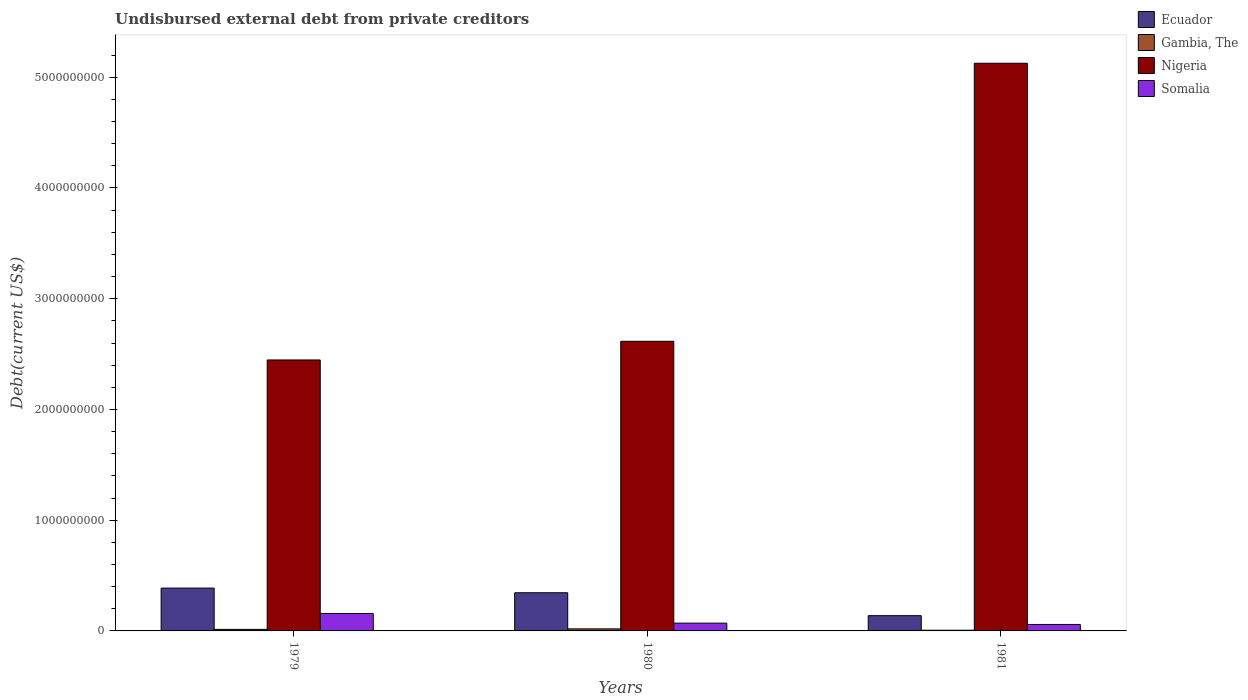How many different coloured bars are there?
Make the answer very short. 4. How many groups of bars are there?
Ensure brevity in your answer.  3. Are the number of bars on each tick of the X-axis equal?
Provide a succinct answer. Yes. How many bars are there on the 1st tick from the left?
Keep it short and to the point. 4. How many bars are there on the 2nd tick from the right?
Make the answer very short. 4. What is the label of the 2nd group of bars from the left?
Provide a succinct answer. 1980. In how many cases, is the number of bars for a given year not equal to the number of legend labels?
Your response must be concise. 0. What is the total debt in Gambia, The in 1980?
Your answer should be very brief. 1.86e+07. Across all years, what is the maximum total debt in Somalia?
Make the answer very short. 1.58e+08. Across all years, what is the minimum total debt in Gambia, The?
Provide a succinct answer. 6.27e+06. What is the total total debt in Ecuador in the graph?
Your answer should be very brief. 8.69e+08. What is the difference between the total debt in Somalia in 1979 and that in 1981?
Your answer should be very brief. 9.94e+07. What is the difference between the total debt in Ecuador in 1981 and the total debt in Somalia in 1979?
Make the answer very short. -1.98e+07. What is the average total debt in Gambia, The per year?
Your response must be concise. 1.29e+07. In the year 1981, what is the difference between the total debt in Nigeria and total debt in Ecuador?
Ensure brevity in your answer.  4.99e+09. What is the ratio of the total debt in Somalia in 1979 to that in 1980?
Give a very brief answer. 2.24. Is the total debt in Ecuador in 1980 less than that in 1981?
Your answer should be very brief. No. Is the difference between the total debt in Nigeria in 1979 and 1980 greater than the difference between the total debt in Ecuador in 1979 and 1980?
Your response must be concise. No. What is the difference between the highest and the second highest total debt in Gambia, The?
Your response must be concise. 4.72e+06. What is the difference between the highest and the lowest total debt in Nigeria?
Offer a very short reply. 2.68e+09. In how many years, is the total debt in Somalia greater than the average total debt in Somalia taken over all years?
Give a very brief answer. 1. Is the sum of the total debt in Nigeria in 1980 and 1981 greater than the maximum total debt in Ecuador across all years?
Offer a terse response. Yes. What does the 4th bar from the left in 1979 represents?
Your response must be concise. Somalia. What does the 3rd bar from the right in 1979 represents?
Your response must be concise. Gambia, The. Is it the case that in every year, the sum of the total debt in Nigeria and total debt in Somalia is greater than the total debt in Gambia, The?
Offer a terse response. Yes. How many bars are there?
Provide a succinct answer. 12. Are all the bars in the graph horizontal?
Make the answer very short. No. Are the values on the major ticks of Y-axis written in scientific E-notation?
Your answer should be compact. No. Does the graph contain grids?
Your answer should be compact. No. How are the legend labels stacked?
Your response must be concise. Vertical. What is the title of the graph?
Keep it short and to the point. Undisbursed external debt from private creditors. Does "Monaco" appear as one of the legend labels in the graph?
Provide a succinct answer. No. What is the label or title of the Y-axis?
Your response must be concise. Debt(current US$). What is the Debt(current US$) in Ecuador in 1979?
Your answer should be very brief. 3.87e+08. What is the Debt(current US$) in Gambia, The in 1979?
Ensure brevity in your answer.  1.39e+07. What is the Debt(current US$) of Nigeria in 1979?
Keep it short and to the point. 2.45e+09. What is the Debt(current US$) of Somalia in 1979?
Provide a succinct answer. 1.58e+08. What is the Debt(current US$) of Ecuador in 1980?
Your answer should be compact. 3.45e+08. What is the Debt(current US$) of Gambia, The in 1980?
Your response must be concise. 1.86e+07. What is the Debt(current US$) of Nigeria in 1980?
Your response must be concise. 2.62e+09. What is the Debt(current US$) in Somalia in 1980?
Provide a short and direct response. 7.03e+07. What is the Debt(current US$) in Ecuador in 1981?
Make the answer very short. 1.38e+08. What is the Debt(current US$) in Gambia, The in 1981?
Offer a terse response. 6.27e+06. What is the Debt(current US$) in Nigeria in 1981?
Offer a very short reply. 5.13e+09. What is the Debt(current US$) of Somalia in 1981?
Ensure brevity in your answer.  5.82e+07. Across all years, what is the maximum Debt(current US$) of Ecuador?
Offer a terse response. 3.87e+08. Across all years, what is the maximum Debt(current US$) of Gambia, The?
Give a very brief answer. 1.86e+07. Across all years, what is the maximum Debt(current US$) of Nigeria?
Offer a terse response. 5.13e+09. Across all years, what is the maximum Debt(current US$) of Somalia?
Offer a terse response. 1.58e+08. Across all years, what is the minimum Debt(current US$) in Ecuador?
Your answer should be very brief. 1.38e+08. Across all years, what is the minimum Debt(current US$) of Gambia, The?
Keep it short and to the point. 6.27e+06. Across all years, what is the minimum Debt(current US$) of Nigeria?
Give a very brief answer. 2.45e+09. Across all years, what is the minimum Debt(current US$) in Somalia?
Make the answer very short. 5.82e+07. What is the total Debt(current US$) of Ecuador in the graph?
Provide a succinct answer. 8.69e+08. What is the total Debt(current US$) in Gambia, The in the graph?
Keep it short and to the point. 3.87e+07. What is the total Debt(current US$) in Nigeria in the graph?
Provide a short and direct response. 1.02e+1. What is the total Debt(current US$) of Somalia in the graph?
Your answer should be very brief. 2.86e+08. What is the difference between the Debt(current US$) in Ecuador in 1979 and that in 1980?
Your response must be concise. 4.21e+07. What is the difference between the Debt(current US$) of Gambia, The in 1979 and that in 1980?
Give a very brief answer. -4.72e+06. What is the difference between the Debt(current US$) in Nigeria in 1979 and that in 1980?
Offer a very short reply. -1.69e+08. What is the difference between the Debt(current US$) in Somalia in 1979 and that in 1980?
Ensure brevity in your answer.  8.73e+07. What is the difference between the Debt(current US$) in Ecuador in 1979 and that in 1981?
Ensure brevity in your answer.  2.49e+08. What is the difference between the Debt(current US$) of Gambia, The in 1979 and that in 1981?
Make the answer very short. 7.60e+06. What is the difference between the Debt(current US$) of Nigeria in 1979 and that in 1981?
Your response must be concise. -2.68e+09. What is the difference between the Debt(current US$) in Somalia in 1979 and that in 1981?
Keep it short and to the point. 9.94e+07. What is the difference between the Debt(current US$) in Ecuador in 1980 and that in 1981?
Ensure brevity in your answer.  2.07e+08. What is the difference between the Debt(current US$) of Gambia, The in 1980 and that in 1981?
Offer a terse response. 1.23e+07. What is the difference between the Debt(current US$) of Nigeria in 1980 and that in 1981?
Your answer should be compact. -2.51e+09. What is the difference between the Debt(current US$) in Somalia in 1980 and that in 1981?
Give a very brief answer. 1.21e+07. What is the difference between the Debt(current US$) in Ecuador in 1979 and the Debt(current US$) in Gambia, The in 1980?
Offer a terse response. 3.68e+08. What is the difference between the Debt(current US$) in Ecuador in 1979 and the Debt(current US$) in Nigeria in 1980?
Provide a short and direct response. -2.23e+09. What is the difference between the Debt(current US$) in Ecuador in 1979 and the Debt(current US$) in Somalia in 1980?
Offer a terse response. 3.16e+08. What is the difference between the Debt(current US$) in Gambia, The in 1979 and the Debt(current US$) in Nigeria in 1980?
Your answer should be very brief. -2.60e+09. What is the difference between the Debt(current US$) in Gambia, The in 1979 and the Debt(current US$) in Somalia in 1980?
Provide a succinct answer. -5.65e+07. What is the difference between the Debt(current US$) of Nigeria in 1979 and the Debt(current US$) of Somalia in 1980?
Make the answer very short. 2.38e+09. What is the difference between the Debt(current US$) of Ecuador in 1979 and the Debt(current US$) of Gambia, The in 1981?
Provide a short and direct response. 3.81e+08. What is the difference between the Debt(current US$) in Ecuador in 1979 and the Debt(current US$) in Nigeria in 1981?
Make the answer very short. -4.74e+09. What is the difference between the Debt(current US$) in Ecuador in 1979 and the Debt(current US$) in Somalia in 1981?
Provide a succinct answer. 3.29e+08. What is the difference between the Debt(current US$) in Gambia, The in 1979 and the Debt(current US$) in Nigeria in 1981?
Keep it short and to the point. -5.11e+09. What is the difference between the Debt(current US$) in Gambia, The in 1979 and the Debt(current US$) in Somalia in 1981?
Keep it short and to the point. -4.43e+07. What is the difference between the Debt(current US$) in Nigeria in 1979 and the Debt(current US$) in Somalia in 1981?
Offer a terse response. 2.39e+09. What is the difference between the Debt(current US$) in Ecuador in 1980 and the Debt(current US$) in Gambia, The in 1981?
Offer a terse response. 3.38e+08. What is the difference between the Debt(current US$) of Ecuador in 1980 and the Debt(current US$) of Nigeria in 1981?
Your answer should be very brief. -4.78e+09. What is the difference between the Debt(current US$) in Ecuador in 1980 and the Debt(current US$) in Somalia in 1981?
Your response must be concise. 2.87e+08. What is the difference between the Debt(current US$) in Gambia, The in 1980 and the Debt(current US$) in Nigeria in 1981?
Offer a very short reply. -5.11e+09. What is the difference between the Debt(current US$) in Gambia, The in 1980 and the Debt(current US$) in Somalia in 1981?
Give a very brief answer. -3.96e+07. What is the difference between the Debt(current US$) in Nigeria in 1980 and the Debt(current US$) in Somalia in 1981?
Keep it short and to the point. 2.56e+09. What is the average Debt(current US$) in Ecuador per year?
Keep it short and to the point. 2.90e+08. What is the average Debt(current US$) of Gambia, The per year?
Provide a succinct answer. 1.29e+07. What is the average Debt(current US$) of Nigeria per year?
Keep it short and to the point. 3.40e+09. What is the average Debt(current US$) in Somalia per year?
Provide a succinct answer. 9.54e+07. In the year 1979, what is the difference between the Debt(current US$) in Ecuador and Debt(current US$) in Gambia, The?
Keep it short and to the point. 3.73e+08. In the year 1979, what is the difference between the Debt(current US$) of Ecuador and Debt(current US$) of Nigeria?
Your answer should be very brief. -2.06e+09. In the year 1979, what is the difference between the Debt(current US$) in Ecuador and Debt(current US$) in Somalia?
Give a very brief answer. 2.29e+08. In the year 1979, what is the difference between the Debt(current US$) in Gambia, The and Debt(current US$) in Nigeria?
Give a very brief answer. -2.43e+09. In the year 1979, what is the difference between the Debt(current US$) in Gambia, The and Debt(current US$) in Somalia?
Give a very brief answer. -1.44e+08. In the year 1979, what is the difference between the Debt(current US$) in Nigeria and Debt(current US$) in Somalia?
Offer a terse response. 2.29e+09. In the year 1980, what is the difference between the Debt(current US$) in Ecuador and Debt(current US$) in Gambia, The?
Provide a short and direct response. 3.26e+08. In the year 1980, what is the difference between the Debt(current US$) of Ecuador and Debt(current US$) of Nigeria?
Your answer should be compact. -2.27e+09. In the year 1980, what is the difference between the Debt(current US$) of Ecuador and Debt(current US$) of Somalia?
Make the answer very short. 2.74e+08. In the year 1980, what is the difference between the Debt(current US$) of Gambia, The and Debt(current US$) of Nigeria?
Make the answer very short. -2.60e+09. In the year 1980, what is the difference between the Debt(current US$) of Gambia, The and Debt(current US$) of Somalia?
Provide a succinct answer. -5.17e+07. In the year 1980, what is the difference between the Debt(current US$) of Nigeria and Debt(current US$) of Somalia?
Your answer should be very brief. 2.55e+09. In the year 1981, what is the difference between the Debt(current US$) in Ecuador and Debt(current US$) in Gambia, The?
Your answer should be very brief. 1.32e+08. In the year 1981, what is the difference between the Debt(current US$) of Ecuador and Debt(current US$) of Nigeria?
Offer a terse response. -4.99e+09. In the year 1981, what is the difference between the Debt(current US$) of Ecuador and Debt(current US$) of Somalia?
Offer a very short reply. 7.96e+07. In the year 1981, what is the difference between the Debt(current US$) of Gambia, The and Debt(current US$) of Nigeria?
Give a very brief answer. -5.12e+09. In the year 1981, what is the difference between the Debt(current US$) in Gambia, The and Debt(current US$) in Somalia?
Your answer should be very brief. -5.19e+07. In the year 1981, what is the difference between the Debt(current US$) in Nigeria and Debt(current US$) in Somalia?
Your response must be concise. 5.07e+09. What is the ratio of the Debt(current US$) of Ecuador in 1979 to that in 1980?
Keep it short and to the point. 1.12. What is the ratio of the Debt(current US$) of Gambia, The in 1979 to that in 1980?
Offer a very short reply. 0.75. What is the ratio of the Debt(current US$) in Nigeria in 1979 to that in 1980?
Make the answer very short. 0.94. What is the ratio of the Debt(current US$) of Somalia in 1979 to that in 1980?
Your response must be concise. 2.24. What is the ratio of the Debt(current US$) of Ecuador in 1979 to that in 1981?
Your response must be concise. 2.81. What is the ratio of the Debt(current US$) in Gambia, The in 1979 to that in 1981?
Ensure brevity in your answer.  2.21. What is the ratio of the Debt(current US$) in Nigeria in 1979 to that in 1981?
Ensure brevity in your answer.  0.48. What is the ratio of the Debt(current US$) of Somalia in 1979 to that in 1981?
Provide a short and direct response. 2.71. What is the ratio of the Debt(current US$) of Ecuador in 1980 to that in 1981?
Offer a very short reply. 2.5. What is the ratio of the Debt(current US$) of Gambia, The in 1980 to that in 1981?
Provide a short and direct response. 2.97. What is the ratio of the Debt(current US$) in Nigeria in 1980 to that in 1981?
Your answer should be compact. 0.51. What is the ratio of the Debt(current US$) in Somalia in 1980 to that in 1981?
Keep it short and to the point. 1.21. What is the difference between the highest and the second highest Debt(current US$) of Ecuador?
Make the answer very short. 4.21e+07. What is the difference between the highest and the second highest Debt(current US$) of Gambia, The?
Make the answer very short. 4.72e+06. What is the difference between the highest and the second highest Debt(current US$) of Nigeria?
Your answer should be compact. 2.51e+09. What is the difference between the highest and the second highest Debt(current US$) of Somalia?
Offer a very short reply. 8.73e+07. What is the difference between the highest and the lowest Debt(current US$) in Ecuador?
Provide a short and direct response. 2.49e+08. What is the difference between the highest and the lowest Debt(current US$) in Gambia, The?
Offer a very short reply. 1.23e+07. What is the difference between the highest and the lowest Debt(current US$) of Nigeria?
Your response must be concise. 2.68e+09. What is the difference between the highest and the lowest Debt(current US$) of Somalia?
Make the answer very short. 9.94e+07. 